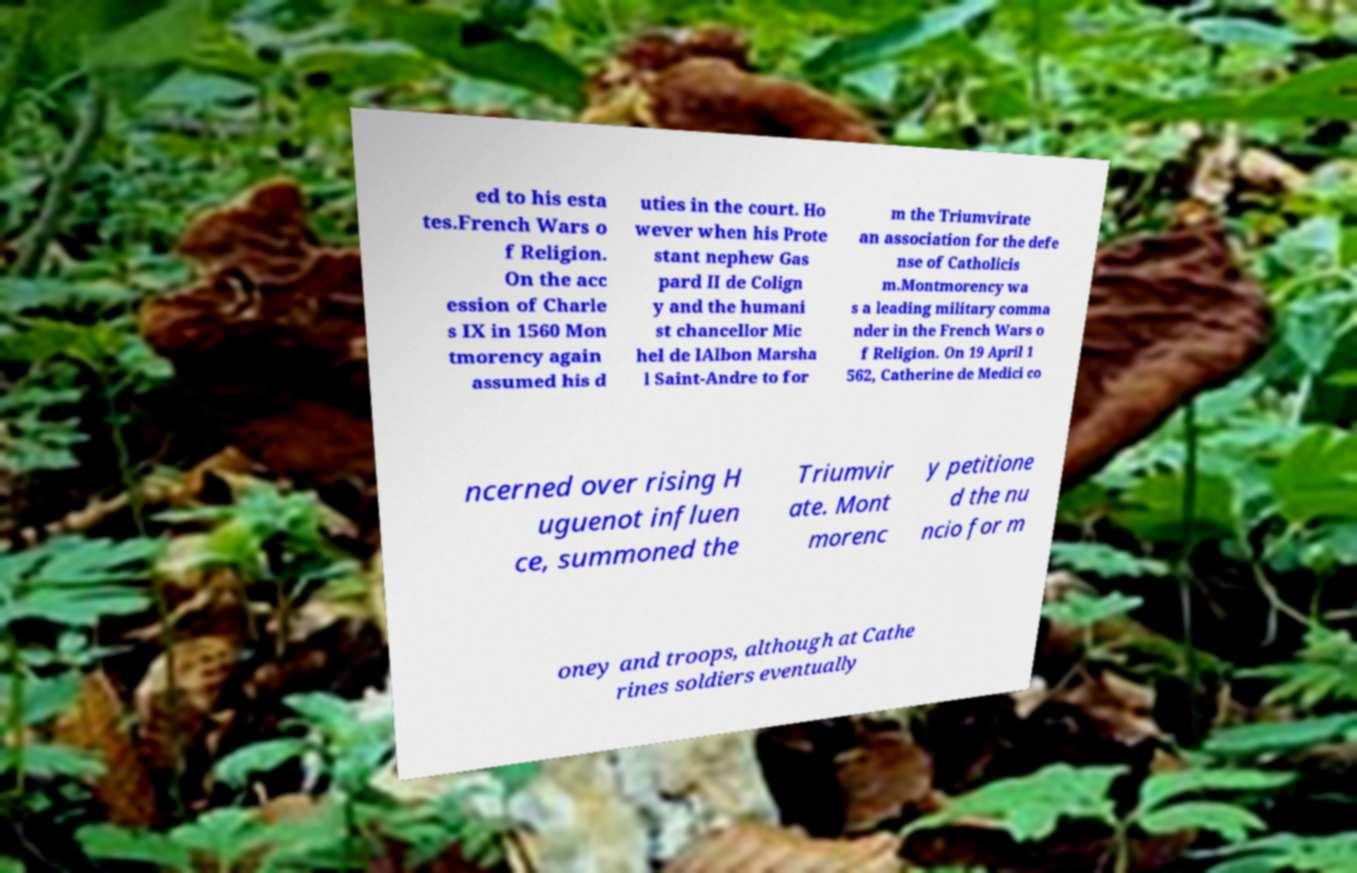What messages or text are displayed in this image? I need them in a readable, typed format. ed to his esta tes.French Wars o f Religion. On the acc ession of Charle s IX in 1560 Mon tmorency again assumed his d uties in the court. Ho wever when his Prote stant nephew Gas pard II de Colign y and the humani st chancellor Mic hel de lAlbon Marsha l Saint-Andre to for m the Triumvirate an association for the defe nse of Catholicis m.Montmorency wa s a leading military comma nder in the French Wars o f Religion. On 19 April 1 562, Catherine de Medici co ncerned over rising H uguenot influen ce, summoned the Triumvir ate. Mont morenc y petitione d the nu ncio for m oney and troops, although at Cathe rines soldiers eventually 